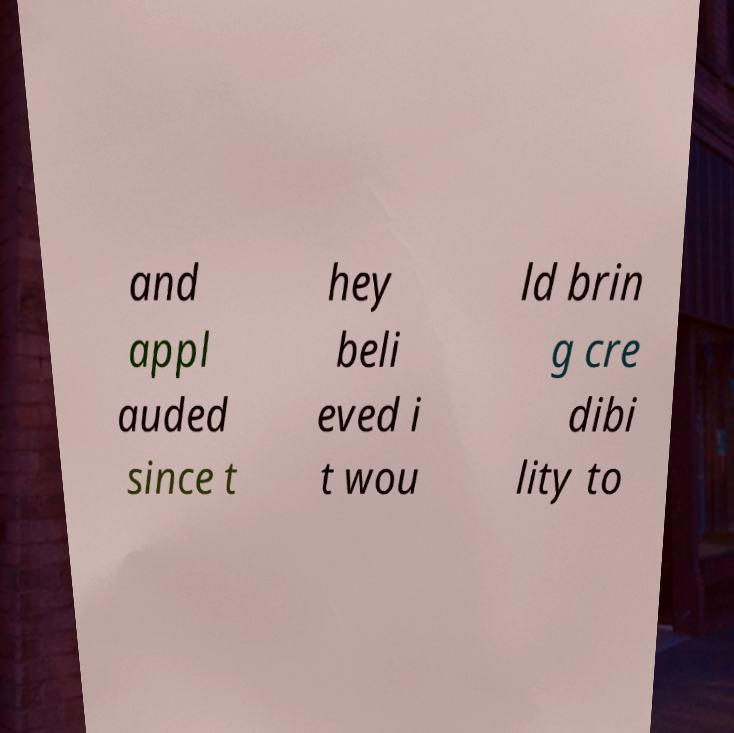Could you extract and type out the text from this image? and appl auded since t hey beli eved i t wou ld brin g cre dibi lity to 